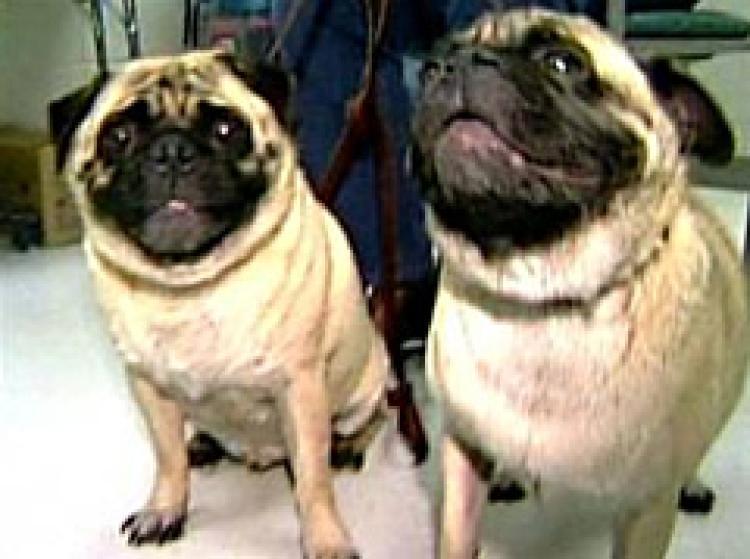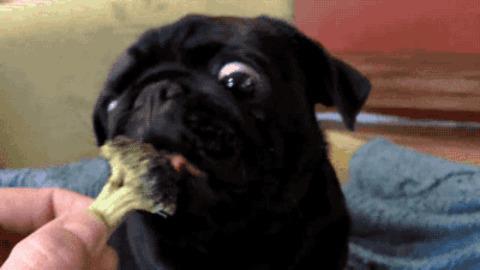The first image is the image on the left, the second image is the image on the right. Analyze the images presented: Is the assertion "An image shows a pug dog chomping on watermelon." valid? Answer yes or no. No. The first image is the image on the left, the second image is the image on the right. Given the left and right images, does the statement "The dog in the image on the left is eating a chunk of watermelon." hold true? Answer yes or no. No. 